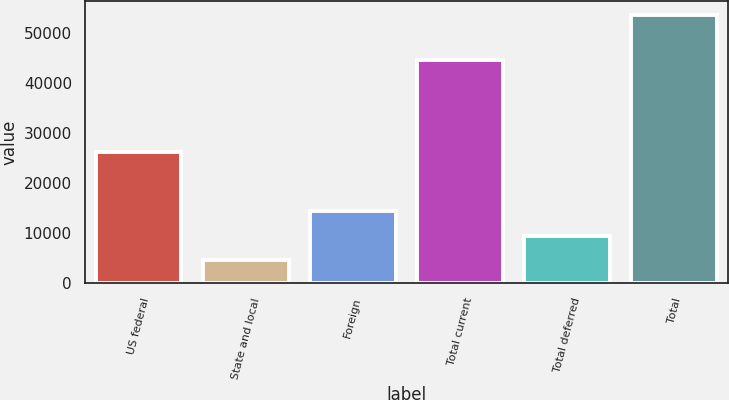Convert chart to OTSL. <chart><loc_0><loc_0><loc_500><loc_500><bar_chart><fcel>US federal<fcel>State and local<fcel>Foreign<fcel>Total current<fcel>Total deferred<fcel>Total<nl><fcel>26204<fcel>4583<fcel>14386.2<fcel>44562<fcel>9484.6<fcel>53599<nl></chart> 